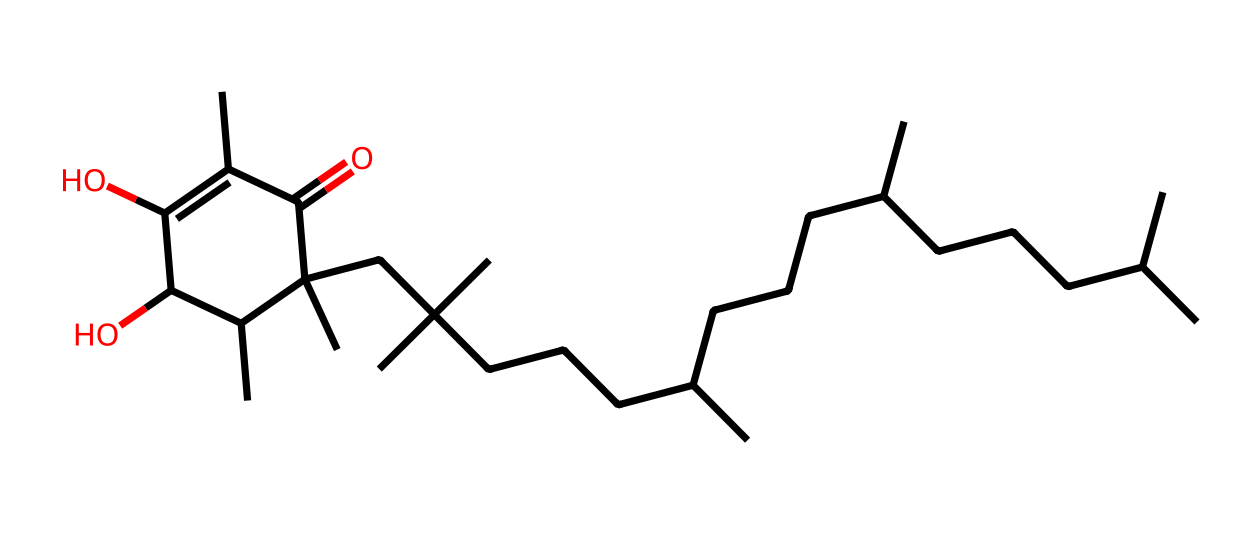What is the molecular formula of vitamin E? To determine the molecular formula from the SMILES representation, we count the number of each type of atom present. In this case, we identify multiple carbon (C) and hydrogen (H) atoms, and an oxygen atom (O). The chemical structure reveals a total of 29 carbons, 50 hydrogens, and 2 oxygens, giving the molecular formula C29H50O2.
Answer: C29H50O2 How many oxygen atoms are in the structure? By analyzing the SMILES representation, we can directly identify the oxygen atoms present in the structure. In this case, there are two 'O' notations in the structure, indicating the presence of two oxygen atoms.
Answer: 2 What type of chemical is vitamin E? Vitamin E is classified as a tocopherol, which is a vitamin and a fat-soluble antioxidant. The presence of specific functional groups and the way it interacts with other molecules confirm its classification.
Answer: tocopherol What characteristic of vitamin E contributes to its antioxidant properties? The presence of hydroxyl (OH) groups in the structure provides the ability to donate hydrogen atoms, stabilizing free radicals, which contributes to vitamin E's antioxidant properties. This functionality explains its beneficial role in skin health.
Answer: hydroxyl groups What is the significance of the long hydrocarbon tail in vitamin E? The long hydrocarbon tail enhances the lipid solubility of vitamin E, allowing it to integrate into cellular membranes and exert its protective effects against oxidation, making it particularly effective for skin health.
Answer: lipid solubility How many rings are present in the structure of vitamin E? By examining the structure, we can identify the presence of one cyclized structure, which shows that there is one ring in the complete molecular structure of vitamin E.
Answer: 1 